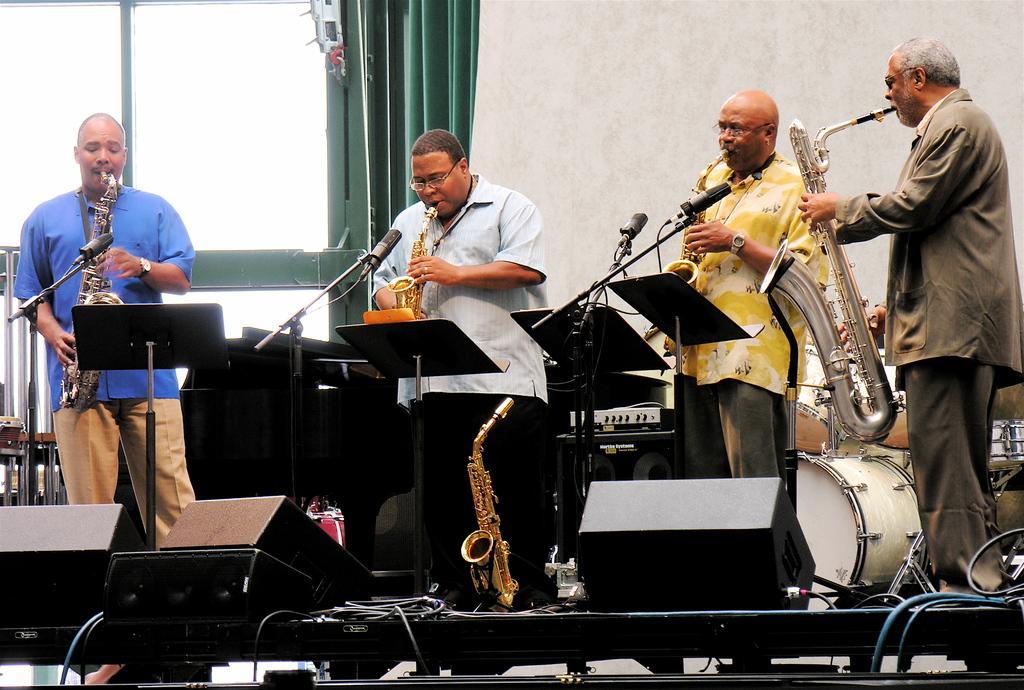Can you describe this image briefly? In the image there are few men playing trumpets in front of mic on a stage with drums behind it and on the left side there is window with curtain. 